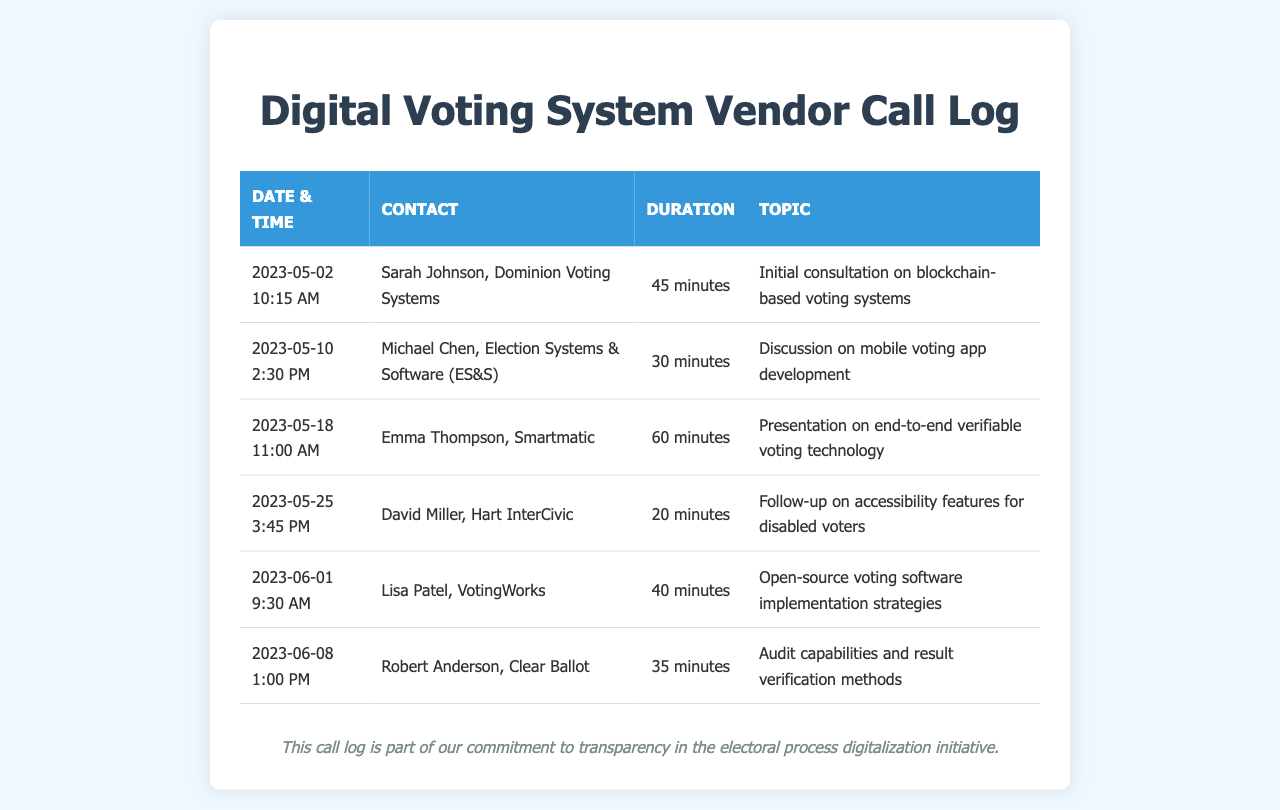What is the call duration for the conversation with Dominion Voting Systems? The call duration for the conversation with Dominion Voting Systems is specified in the document.
Answer: 45 minutes Who was the contact for the discussion on mobile voting app development? The contact information for the conversation about mobile voting app development is listed in the document.
Answer: Michael Chen, Election Systems & Software (ES&S) On what date was the presentation on end-to-end verifiable voting technology held? The date of the presentation on end-to-end verifiable voting technology can be found in the document.
Answer: 2023-05-18 How many minutes was the call regarding accessibility features for disabled voters? The duration of the call regarding accessibility features for disabled voters is detailed in the document.
Answer: 20 minutes Which vendor was discussed on June 1? The vendor discussed on June 1 is mentioned in the conversation logs in the document.
Answer: VotingWorks What is the main topic of conversation with Clear Ballot? The main topic of conversation with Clear Ballot is provided in the document's details.
Answer: Audit capabilities and result verification methods Which vendor had the longest call duration? The call duration for each vendor is provided, allowing for a comparison to find the longest.
Answer: Emma Thompson, Smartmatic How many calls were logged in total? The total number of calls is the count of the individual entries in the document.
Answer: 6 